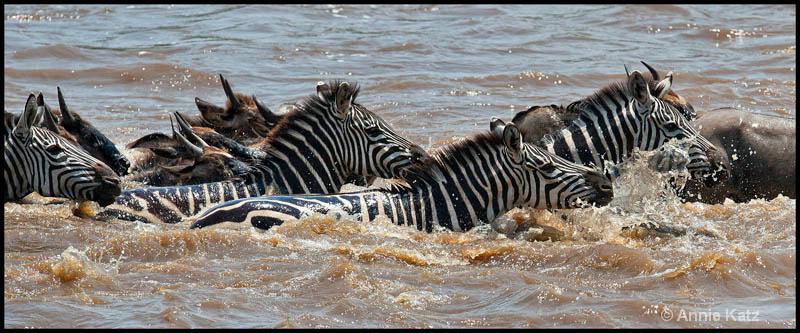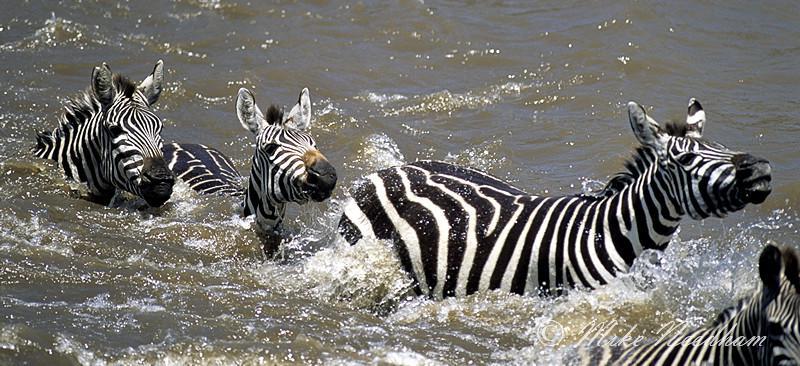The first image is the image on the left, the second image is the image on the right. Evaluate the accuracy of this statement regarding the images: "There are exactly three zebras.". Is it true? Answer yes or no. No. The first image is the image on the left, the second image is the image on the right. Assess this claim about the two images: "The right image shows exactly two zebra heading leftward in neck-deep water, one behind the other, and the left image features a zebra with a different type of animal in the water.". Correct or not? Answer yes or no. No. 